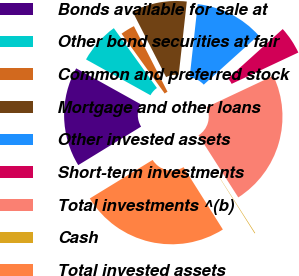Convert chart. <chart><loc_0><loc_0><loc_500><loc_500><pie_chart><fcel>Bonds available for sale at<fcel>Other bond securities at fair<fcel>Common and preferred stock<fcel>Mortgage and other loans<fcel>Other invested assets<fcel>Short-term investments<fcel>Total investments ^(b)<fcel>Cash<fcel>Total invested assets<nl><fcel>16.82%<fcel>6.99%<fcel>2.4%<fcel>9.28%<fcel>11.57%<fcel>4.69%<fcel>22.92%<fcel>0.11%<fcel>25.21%<nl></chart> 